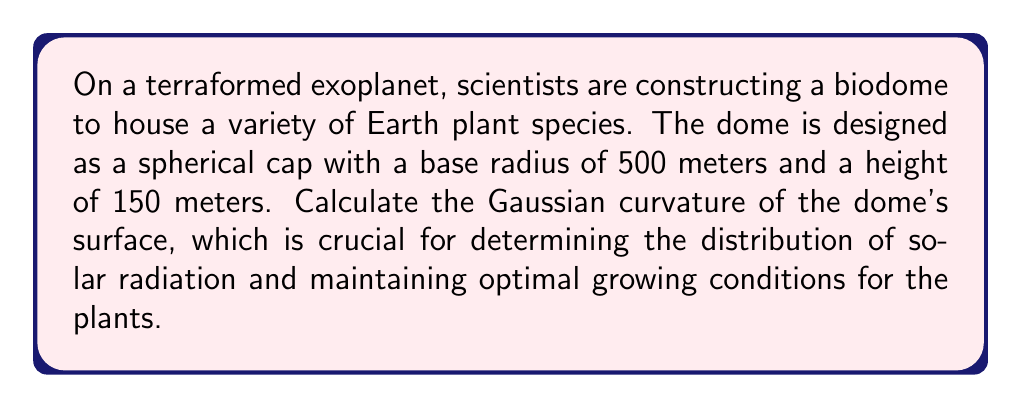Show me your answer to this math problem. To solve this problem, we'll follow these steps:

1) The Gaussian curvature of a sphere is constant and equal to $\frac{1}{R^2}$, where $R$ is the radius of the sphere.

2) We need to find the radius of the sphere that this spherical cap is a part of. We can do this using the equation for a spherical cap:

   $$h = R - \sqrt{R^2 - r^2}$$

   where $h$ is the height of the cap, $R$ is the radius of the sphere, and $r$ is the base radius of the cap.

3) We know $h = 150$ m and $r = 500$ m. Let's substitute these into the equation:

   $$150 = R - \sqrt{R^2 - 500^2}$$

4) Solving this equation:
   
   $$\sqrt{R^2 - 500^2} = R - 150$$
   $$(R^2 - 500^2) = (R - 150)^2$$
   $$R^2 - 500^2 = R^2 - 300R + 22500$$
   $$300R = 522500$$
   $$R = 1741.67$$ meters (rounded to 2 decimal places)

5) Now that we have the radius of the sphere, we can calculate the Gaussian curvature:

   $$K = \frac{1}{R^2} = \frac{1}{1741.67^2} \approx 3.29 \times 10^{-7}$$ m^(-2)

[asy]
import geometry;

size(200);
pair O = (0,0);
real R = 100;
real h = 8.61;
real r = 28.71;

draw(circle(O,R));
draw((0,R-h)--(-r,R-h)--(r,R-h));
draw(O--(R,0));
draw(O--(r,R-h));
label("R", (R/2,0), S);
label("r", (r/2,R-h), N);
label("h", (r+2,R-h/2), E);

[/asy]
Answer: $3.29 \times 10^{-7}$ m^(-2) 